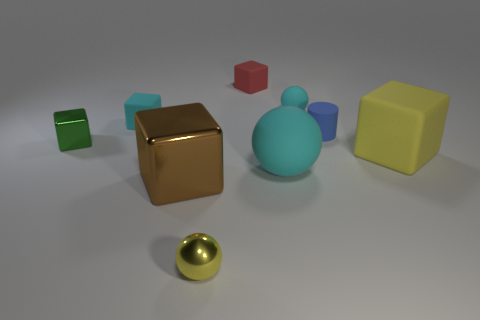Subtract all brown cubes. How many cubes are left? 4 Subtract all green cubes. How many cubes are left? 4 Subtract all purple blocks. Subtract all yellow balls. How many blocks are left? 5 Add 1 rubber cylinders. How many objects exist? 10 Subtract all cylinders. How many objects are left? 8 Subtract 1 brown blocks. How many objects are left? 8 Subtract all tiny matte things. Subtract all tiny red rubber spheres. How many objects are left? 5 Add 6 matte cylinders. How many matte cylinders are left? 7 Add 5 cyan spheres. How many cyan spheres exist? 7 